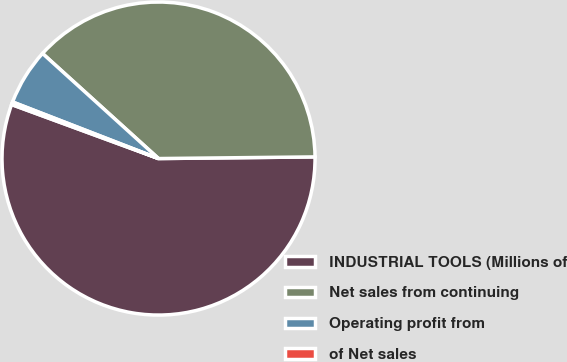Convert chart to OTSL. <chart><loc_0><loc_0><loc_500><loc_500><pie_chart><fcel>INDUSTRIAL TOOLS (Millions of<fcel>Net sales from continuing<fcel>Operating profit from<fcel>of Net sales<nl><fcel>55.78%<fcel>38.12%<fcel>5.83%<fcel>0.28%<nl></chart> 